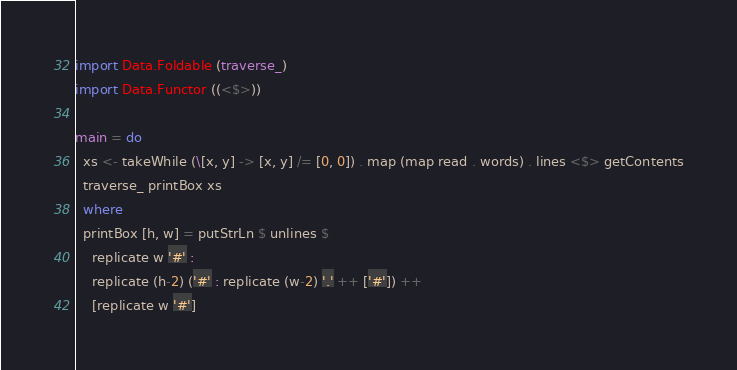Convert code to text. <code><loc_0><loc_0><loc_500><loc_500><_Haskell_>import Data.Foldable (traverse_)
import Data.Functor ((<$>))

main = do
  xs <- takeWhile (\[x, y] -> [x, y] /= [0, 0]) . map (map read . words) . lines <$> getContents
  traverse_ printBox xs
  where
  printBox [h, w] = putStrLn $ unlines $
    replicate w '#' :
    replicate (h-2) ('#' : replicate (w-2) '.' ++ ['#']) ++
    [replicate w '#']

</code> 